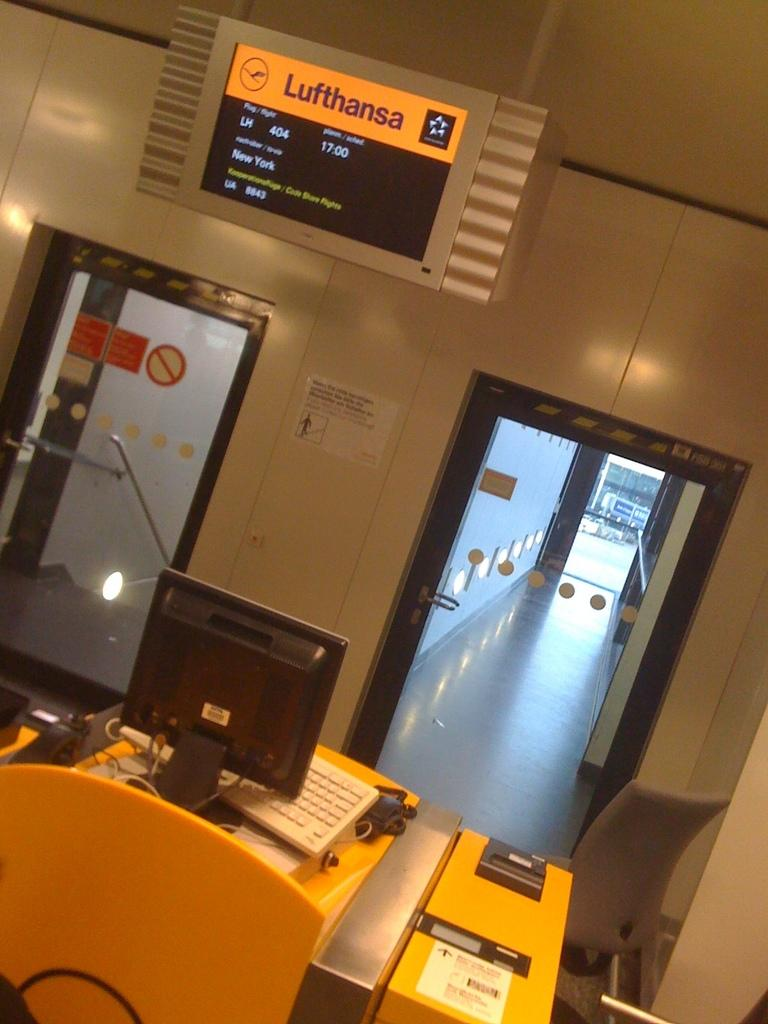<image>
Offer a succinct explanation of the picture presented. A sign states flight 404 information for Lufthansa airlines. 